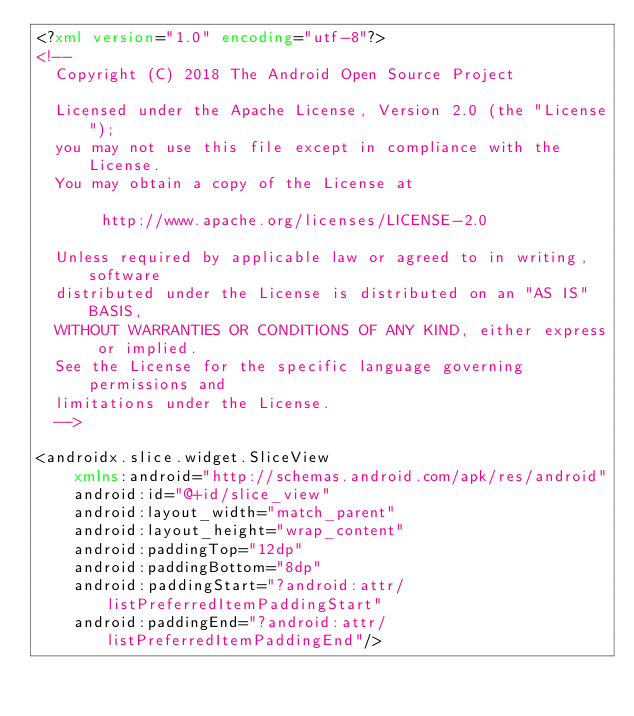Convert code to text. <code><loc_0><loc_0><loc_500><loc_500><_XML_><?xml version="1.0" encoding="utf-8"?>
<!--
  Copyright (C) 2018 The Android Open Source Project

  Licensed under the Apache License, Version 2.0 (the "License");
  you may not use this file except in compliance with the License.
  You may obtain a copy of the License at

       http://www.apache.org/licenses/LICENSE-2.0

  Unless required by applicable law or agreed to in writing, software
  distributed under the License is distributed on an "AS IS" BASIS,
  WITHOUT WARRANTIES OR CONDITIONS OF ANY KIND, either express or implied.
  See the License for the specific language governing permissions and
  limitations under the License.
  -->

<androidx.slice.widget.SliceView
    xmlns:android="http://schemas.android.com/apk/res/android"
    android:id="@+id/slice_view"
    android:layout_width="match_parent"
    android:layout_height="wrap_content"
    android:paddingTop="12dp"
    android:paddingBottom="8dp"
    android:paddingStart="?android:attr/listPreferredItemPaddingStart"
    android:paddingEnd="?android:attr/listPreferredItemPaddingEnd"/></code> 